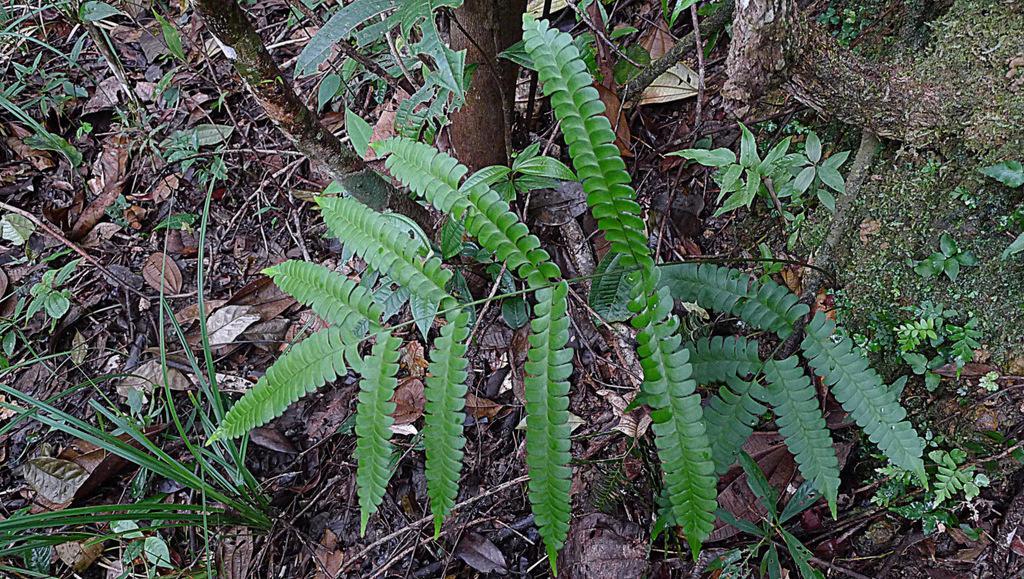Describe this image in one or two sentences. In this picture we can see plants, dried leaves and grass. We can also see the barks of a tree. 